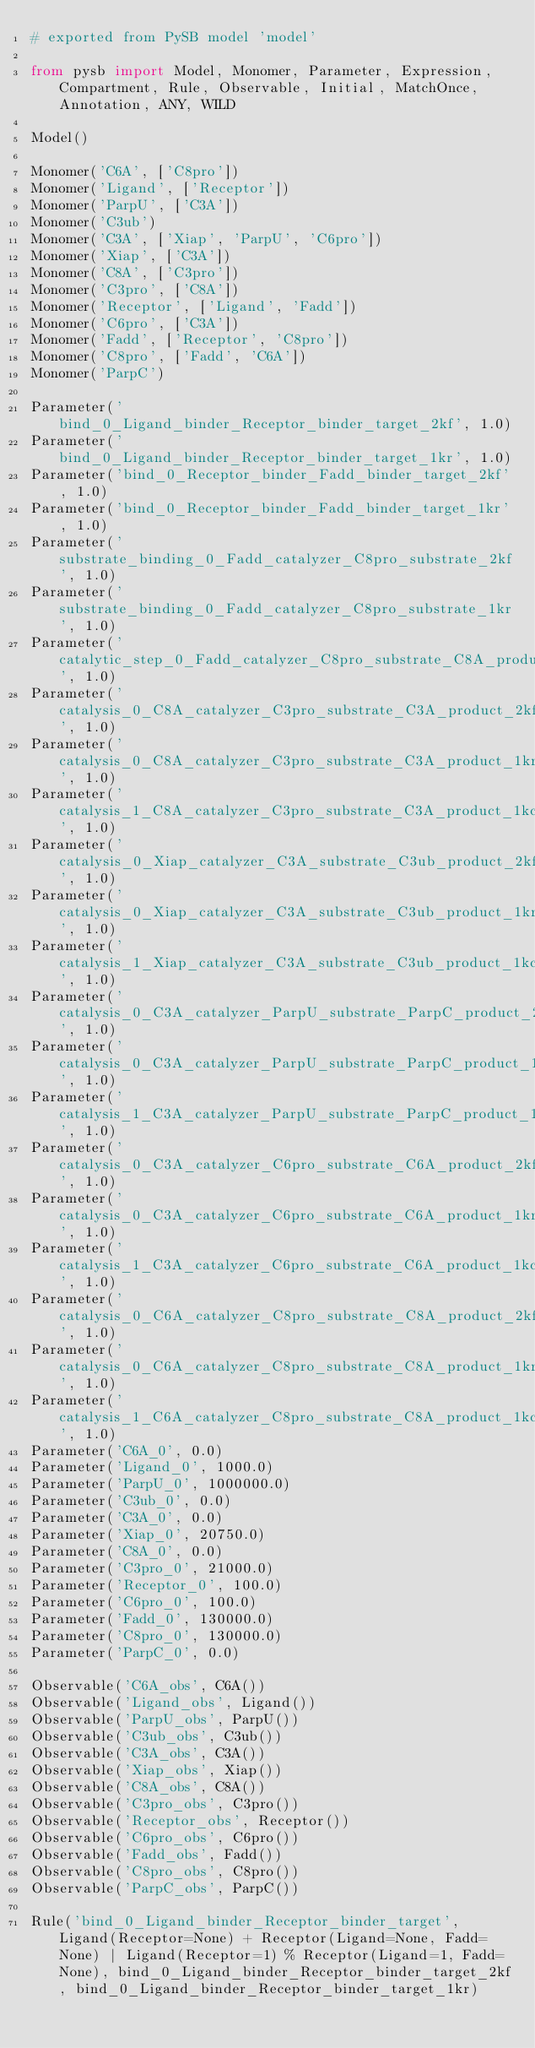<code> <loc_0><loc_0><loc_500><loc_500><_Python_># exported from PySB model 'model'

from pysb import Model, Monomer, Parameter, Expression, Compartment, Rule, Observable, Initial, MatchOnce, Annotation, ANY, WILD

Model()

Monomer('C6A', ['C8pro'])
Monomer('Ligand', ['Receptor'])
Monomer('ParpU', ['C3A'])
Monomer('C3ub')
Monomer('C3A', ['Xiap', 'ParpU', 'C6pro'])
Monomer('Xiap', ['C3A'])
Monomer('C8A', ['C3pro'])
Monomer('C3pro', ['C8A'])
Monomer('Receptor', ['Ligand', 'Fadd'])
Monomer('C6pro', ['C3A'])
Monomer('Fadd', ['Receptor', 'C8pro'])
Monomer('C8pro', ['Fadd', 'C6A'])
Monomer('ParpC')

Parameter('bind_0_Ligand_binder_Receptor_binder_target_2kf', 1.0)
Parameter('bind_0_Ligand_binder_Receptor_binder_target_1kr', 1.0)
Parameter('bind_0_Receptor_binder_Fadd_binder_target_2kf', 1.0)
Parameter('bind_0_Receptor_binder_Fadd_binder_target_1kr', 1.0)
Parameter('substrate_binding_0_Fadd_catalyzer_C8pro_substrate_2kf', 1.0)
Parameter('substrate_binding_0_Fadd_catalyzer_C8pro_substrate_1kr', 1.0)
Parameter('catalytic_step_0_Fadd_catalyzer_C8pro_substrate_C8A_product_1kc', 1.0)
Parameter('catalysis_0_C8A_catalyzer_C3pro_substrate_C3A_product_2kf', 1.0)
Parameter('catalysis_0_C8A_catalyzer_C3pro_substrate_C3A_product_1kr', 1.0)
Parameter('catalysis_1_C8A_catalyzer_C3pro_substrate_C3A_product_1kc', 1.0)
Parameter('catalysis_0_Xiap_catalyzer_C3A_substrate_C3ub_product_2kf', 1.0)
Parameter('catalysis_0_Xiap_catalyzer_C3A_substrate_C3ub_product_1kr', 1.0)
Parameter('catalysis_1_Xiap_catalyzer_C3A_substrate_C3ub_product_1kc', 1.0)
Parameter('catalysis_0_C3A_catalyzer_ParpU_substrate_ParpC_product_2kf', 1.0)
Parameter('catalysis_0_C3A_catalyzer_ParpU_substrate_ParpC_product_1kr', 1.0)
Parameter('catalysis_1_C3A_catalyzer_ParpU_substrate_ParpC_product_1kc', 1.0)
Parameter('catalysis_0_C3A_catalyzer_C6pro_substrate_C6A_product_2kf', 1.0)
Parameter('catalysis_0_C3A_catalyzer_C6pro_substrate_C6A_product_1kr', 1.0)
Parameter('catalysis_1_C3A_catalyzer_C6pro_substrate_C6A_product_1kc', 1.0)
Parameter('catalysis_0_C6A_catalyzer_C8pro_substrate_C8A_product_2kf', 1.0)
Parameter('catalysis_0_C6A_catalyzer_C8pro_substrate_C8A_product_1kr', 1.0)
Parameter('catalysis_1_C6A_catalyzer_C8pro_substrate_C8A_product_1kc', 1.0)
Parameter('C6A_0', 0.0)
Parameter('Ligand_0', 1000.0)
Parameter('ParpU_0', 1000000.0)
Parameter('C3ub_0', 0.0)
Parameter('C3A_0', 0.0)
Parameter('Xiap_0', 20750.0)
Parameter('C8A_0', 0.0)
Parameter('C3pro_0', 21000.0)
Parameter('Receptor_0', 100.0)
Parameter('C6pro_0', 100.0)
Parameter('Fadd_0', 130000.0)
Parameter('C8pro_0', 130000.0)
Parameter('ParpC_0', 0.0)

Observable('C6A_obs', C6A())
Observable('Ligand_obs', Ligand())
Observable('ParpU_obs', ParpU())
Observable('C3ub_obs', C3ub())
Observable('C3A_obs', C3A())
Observable('Xiap_obs', Xiap())
Observable('C8A_obs', C8A())
Observable('C3pro_obs', C3pro())
Observable('Receptor_obs', Receptor())
Observable('C6pro_obs', C6pro())
Observable('Fadd_obs', Fadd())
Observable('C8pro_obs', C8pro())
Observable('ParpC_obs', ParpC())

Rule('bind_0_Ligand_binder_Receptor_binder_target', Ligand(Receptor=None) + Receptor(Ligand=None, Fadd=None) | Ligand(Receptor=1) % Receptor(Ligand=1, Fadd=None), bind_0_Ligand_binder_Receptor_binder_target_2kf, bind_0_Ligand_binder_Receptor_binder_target_1kr)</code> 